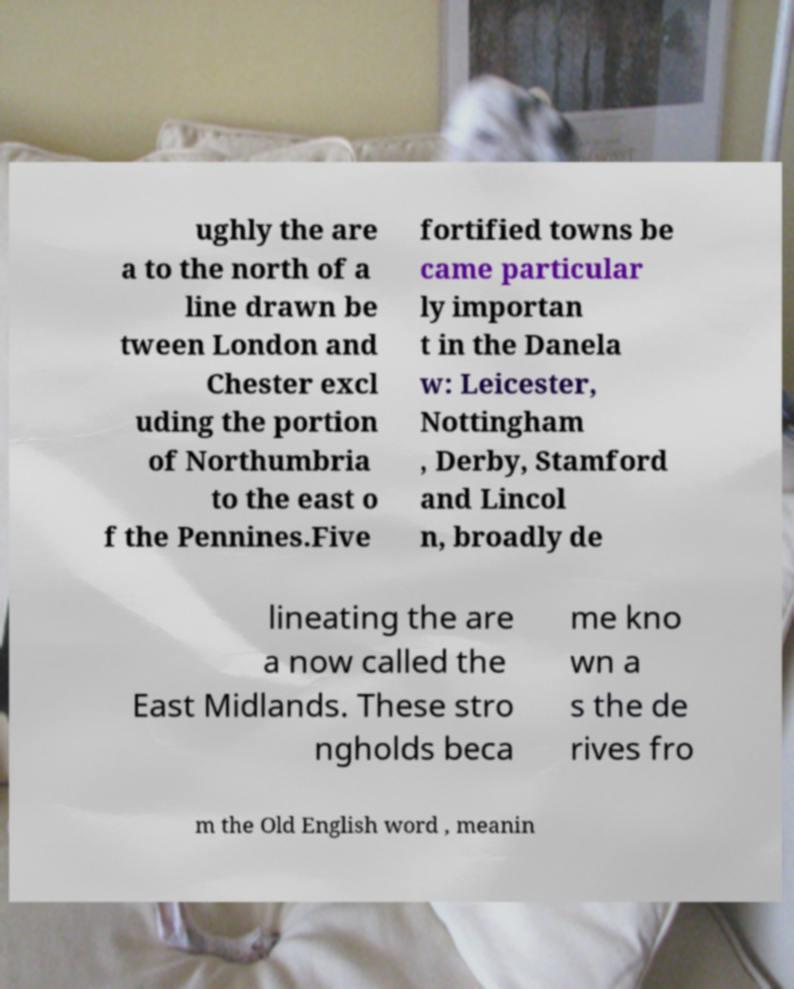What messages or text are displayed in this image? I need them in a readable, typed format. ughly the are a to the north of a line drawn be tween London and Chester excl uding the portion of Northumbria to the east o f the Pennines.Five fortified towns be came particular ly importan t in the Danela w: Leicester, Nottingham , Derby, Stamford and Lincol n, broadly de lineating the are a now called the East Midlands. These stro ngholds beca me kno wn a s the de rives fro m the Old English word , meanin 